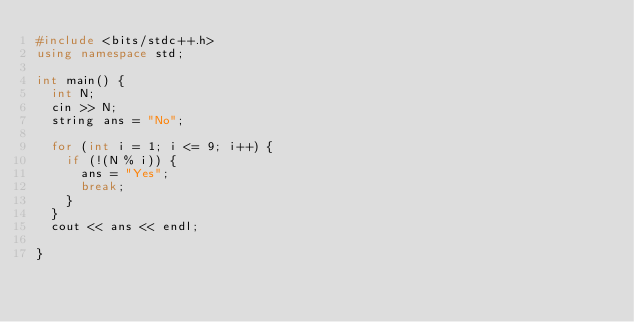<code> <loc_0><loc_0><loc_500><loc_500><_C++_>#include <bits/stdc++.h>
using namespace std;

int main() {
  int N;
  cin >> N;
  string ans = "No";

  for (int i = 1; i <= 9; i++) {
    if (!(N % i)) {
      ans = "Yes";
      break;
    }
  }
  cout << ans << endl;

}
</code> 